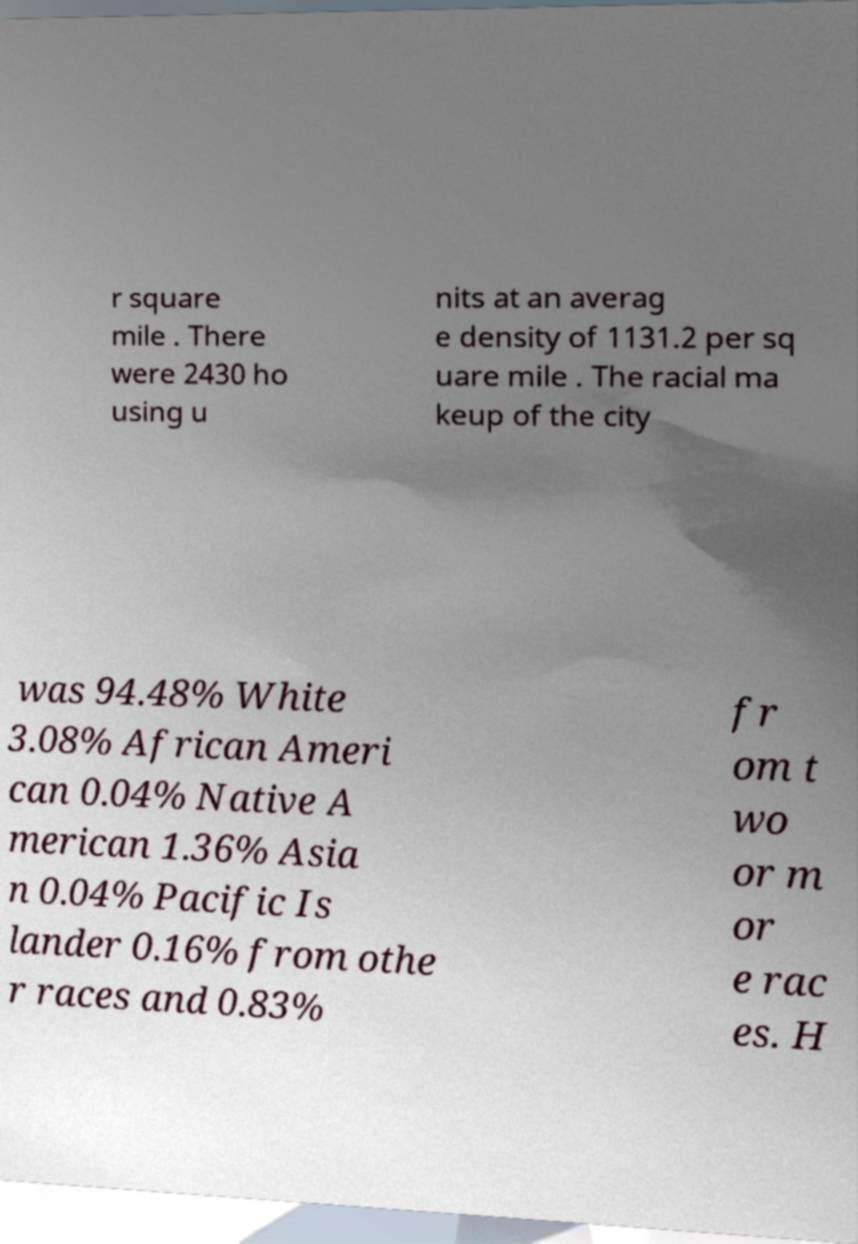Please read and relay the text visible in this image. What does it say? r square mile . There were 2430 ho using u nits at an averag e density of 1131.2 per sq uare mile . The racial ma keup of the city was 94.48% White 3.08% African Ameri can 0.04% Native A merican 1.36% Asia n 0.04% Pacific Is lander 0.16% from othe r races and 0.83% fr om t wo or m or e rac es. H 